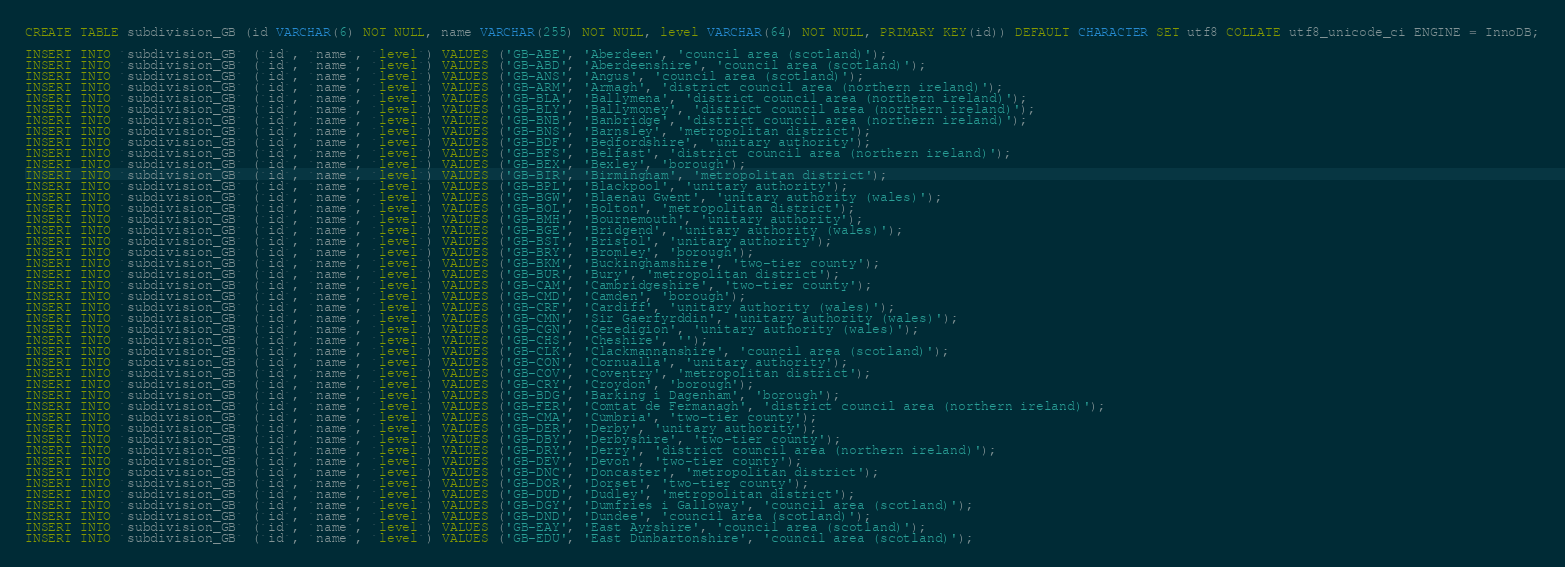Convert code to text. <code><loc_0><loc_0><loc_500><loc_500><_SQL_>CREATE TABLE subdivision_GB (id VARCHAR(6) NOT NULL, name VARCHAR(255) NOT NULL, level VARCHAR(64) NOT NULL, PRIMARY KEY(id)) DEFAULT CHARACTER SET utf8 COLLATE utf8_unicode_ci ENGINE = InnoDB;

INSERT INTO `subdivision_GB` (`id`, `name`, `level`) VALUES ('GB-ABE', 'Aberdeen', 'council area (scotland)');
INSERT INTO `subdivision_GB` (`id`, `name`, `level`) VALUES ('GB-ABD', 'Aberdeenshire', 'council area (scotland)');
INSERT INTO `subdivision_GB` (`id`, `name`, `level`) VALUES ('GB-ANS', 'Angus', 'council area (scotland)');
INSERT INTO `subdivision_GB` (`id`, `name`, `level`) VALUES ('GB-ARM', 'Armagh', 'district council area (northern ireland)');
INSERT INTO `subdivision_GB` (`id`, `name`, `level`) VALUES ('GB-BLA', 'Ballymena', 'district council area (northern ireland)');
INSERT INTO `subdivision_GB` (`id`, `name`, `level`) VALUES ('GB-BLY', 'Ballymoney', 'district council area (northern ireland)');
INSERT INTO `subdivision_GB` (`id`, `name`, `level`) VALUES ('GB-BNB', 'Banbridge', 'district council area (northern ireland)');
INSERT INTO `subdivision_GB` (`id`, `name`, `level`) VALUES ('GB-BNS', 'Barnsley', 'metropolitan district');
INSERT INTO `subdivision_GB` (`id`, `name`, `level`) VALUES ('GB-BDF', 'Bedfordshire', 'unitary authority');
INSERT INTO `subdivision_GB` (`id`, `name`, `level`) VALUES ('GB-BFS', 'Belfast', 'district council area (northern ireland)');
INSERT INTO `subdivision_GB` (`id`, `name`, `level`) VALUES ('GB-BEX', 'Bexley', 'borough');
INSERT INTO `subdivision_GB` (`id`, `name`, `level`) VALUES ('GB-BIR', 'Birmingham', 'metropolitan district');
INSERT INTO `subdivision_GB` (`id`, `name`, `level`) VALUES ('GB-BPL', 'Blackpool', 'unitary authority');
INSERT INTO `subdivision_GB` (`id`, `name`, `level`) VALUES ('GB-BGW', 'Blaenau Gwent', 'unitary authority (wales)');
INSERT INTO `subdivision_GB` (`id`, `name`, `level`) VALUES ('GB-BOL', 'Bolton', 'metropolitan district');
INSERT INTO `subdivision_GB` (`id`, `name`, `level`) VALUES ('GB-BMH', 'Bournemouth', 'unitary authority');
INSERT INTO `subdivision_GB` (`id`, `name`, `level`) VALUES ('GB-BGE', 'Bridgend', 'unitary authority (wales)');
INSERT INTO `subdivision_GB` (`id`, `name`, `level`) VALUES ('GB-BST', 'Bristol', 'unitary authority');
INSERT INTO `subdivision_GB` (`id`, `name`, `level`) VALUES ('GB-BRY', 'Bromley', 'borough');
INSERT INTO `subdivision_GB` (`id`, `name`, `level`) VALUES ('GB-BKM', 'Buckinghamshire', 'two-tier county');
INSERT INTO `subdivision_GB` (`id`, `name`, `level`) VALUES ('GB-BUR', 'Bury', 'metropolitan district');
INSERT INTO `subdivision_GB` (`id`, `name`, `level`) VALUES ('GB-CAM', 'Cambridgeshire', 'two-tier county');
INSERT INTO `subdivision_GB` (`id`, `name`, `level`) VALUES ('GB-CMD', 'Camden', 'borough');
INSERT INTO `subdivision_GB` (`id`, `name`, `level`) VALUES ('GB-CRF', 'Cardiff', 'unitary authority (wales)');
INSERT INTO `subdivision_GB` (`id`, `name`, `level`) VALUES ('GB-CMN', 'Sir Gaerfyrddin', 'unitary authority (wales)');
INSERT INTO `subdivision_GB` (`id`, `name`, `level`) VALUES ('GB-CGN', 'Ceredigion', 'unitary authority (wales)');
INSERT INTO `subdivision_GB` (`id`, `name`, `level`) VALUES ('GB-CHS', 'Cheshire', '');
INSERT INTO `subdivision_GB` (`id`, `name`, `level`) VALUES ('GB-CLK', 'Clackmannanshire', 'council area (scotland)');
INSERT INTO `subdivision_GB` (`id`, `name`, `level`) VALUES ('GB-CON', 'Cornualla', 'unitary authority');
INSERT INTO `subdivision_GB` (`id`, `name`, `level`) VALUES ('GB-COV', 'Coventry', 'metropolitan district');
INSERT INTO `subdivision_GB` (`id`, `name`, `level`) VALUES ('GB-CRY', 'Croydon', 'borough');
INSERT INTO `subdivision_GB` (`id`, `name`, `level`) VALUES ('GB-BDG', 'Barking i Dagenham', 'borough');
INSERT INTO `subdivision_GB` (`id`, `name`, `level`) VALUES ('GB-FER', 'Comtat de Fermanagh', 'district council area (northern ireland)');
INSERT INTO `subdivision_GB` (`id`, `name`, `level`) VALUES ('GB-CMA', 'Cúmbria', 'two-tier county');
INSERT INTO `subdivision_GB` (`id`, `name`, `level`) VALUES ('GB-DER', 'Derby', 'unitary authority');
INSERT INTO `subdivision_GB` (`id`, `name`, `level`) VALUES ('GB-DBY', 'Derbyshire', 'two-tier county');
INSERT INTO `subdivision_GB` (`id`, `name`, `level`) VALUES ('GB-DRY', 'Derry', 'district council area (northern ireland)');
INSERT INTO `subdivision_GB` (`id`, `name`, `level`) VALUES ('GB-DEV', 'Devon', 'two-tier county');
INSERT INTO `subdivision_GB` (`id`, `name`, `level`) VALUES ('GB-DNC', 'Doncaster', 'metropolitan district');
INSERT INTO `subdivision_GB` (`id`, `name`, `level`) VALUES ('GB-DOR', 'Dorset', 'two-tier county');
INSERT INTO `subdivision_GB` (`id`, `name`, `level`) VALUES ('GB-DUD', 'Dudley', 'metropolitan district');
INSERT INTO `subdivision_GB` (`id`, `name`, `level`) VALUES ('GB-DGY', 'Dumfries i Galloway', 'council area (scotland)');
INSERT INTO `subdivision_GB` (`id`, `name`, `level`) VALUES ('GB-DND', 'Dundee', 'council area (scotland)');
INSERT INTO `subdivision_GB` (`id`, `name`, `level`) VALUES ('GB-EAY', 'East Ayrshire', 'council area (scotland)');
INSERT INTO `subdivision_GB` (`id`, `name`, `level`) VALUES ('GB-EDU', 'East Dunbartonshire', 'council area (scotland)');</code> 